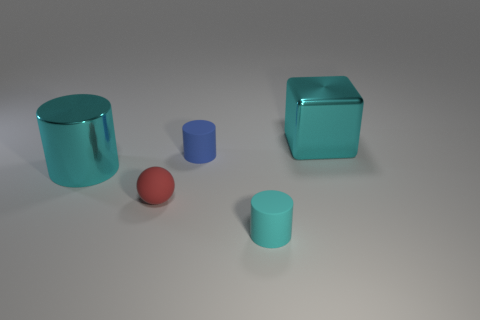Subtract all cyan cylinders. How many cylinders are left? 1 Subtract all spheres. How many objects are left? 4 Add 4 cyan shiny things. How many objects exist? 9 Subtract all blue cylinders. How many cylinders are left? 2 Subtract all blue cubes. How many cyan cylinders are left? 2 Subtract all rubber objects. Subtract all small cyan matte objects. How many objects are left? 1 Add 3 tiny red balls. How many tiny red balls are left? 4 Add 2 big brown rubber balls. How many big brown rubber balls exist? 2 Subtract 0 gray cylinders. How many objects are left? 5 Subtract 2 cylinders. How many cylinders are left? 1 